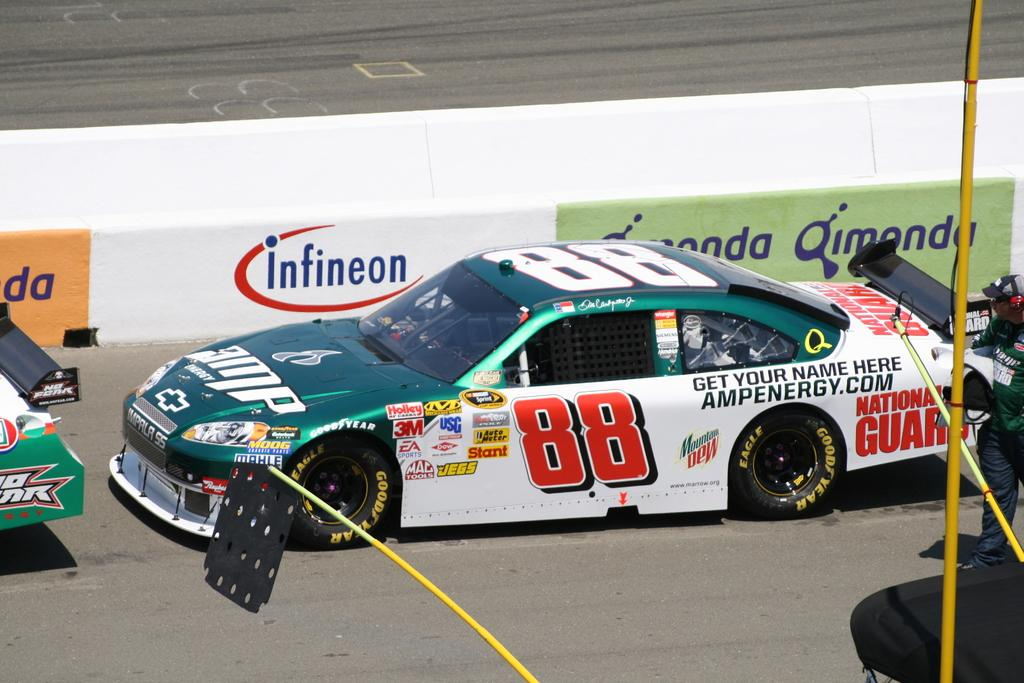What is the main subject of the image? The main subject of the image is a car. Where is the car located in the image? The car is on the road in the image. What features can be seen on the car? The car has a windshield and tires. Is there anyone near the car in the image? Yes, there is a person standing at the back of the car. What else is present in the image besides the car and the person? There is a pole in the image. Can you tell me how many quarters are visible in the image? There are no quarters present in the image. What type of receipt can be seen on the car's windshield in the image? There is no receipt visible on the car's windshield in the image. 